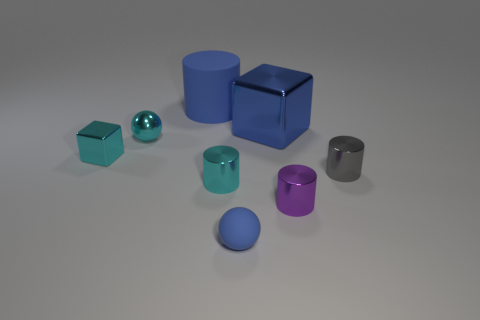Subtract 1 cylinders. How many cylinders are left? 3 Add 1 small blue matte things. How many objects exist? 9 Subtract all balls. How many objects are left? 6 Subtract 1 cyan balls. How many objects are left? 7 Subtract all large metal cubes. Subtract all small cyan shiny cylinders. How many objects are left? 6 Add 8 tiny blue balls. How many tiny blue balls are left? 9 Add 3 big blue cylinders. How many big blue cylinders exist? 4 